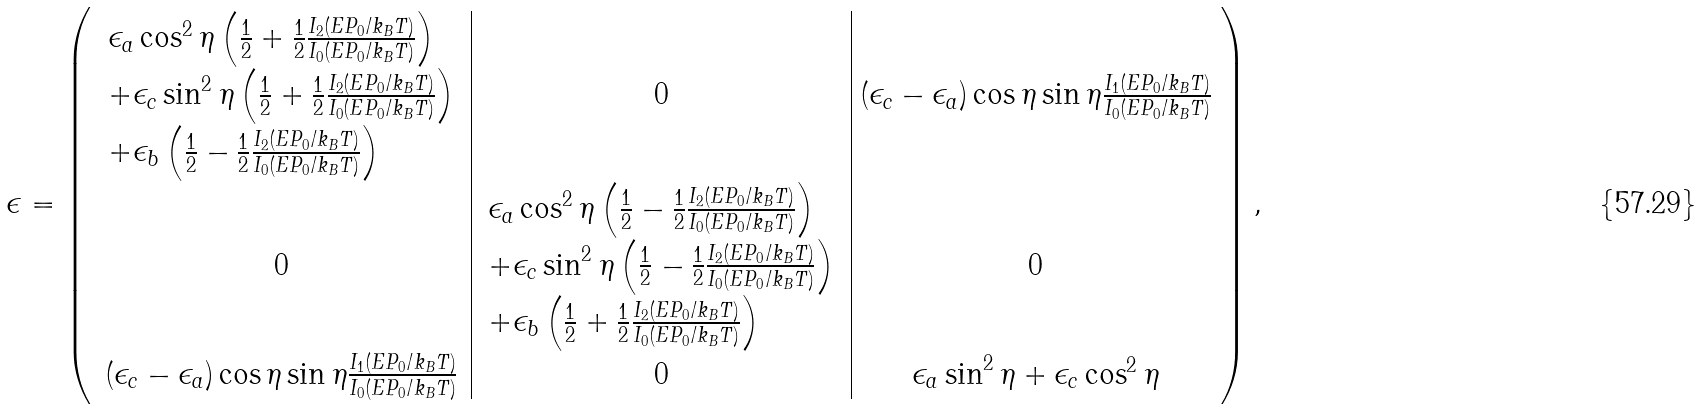<formula> <loc_0><loc_0><loc_500><loc_500>\epsilon = \left ( \begin{array} { c | c | c } \begin{array} { l } \epsilon _ { a } \cos ^ { 2 } \eta \left ( \frac { 1 } { 2 } + \frac { 1 } { 2 } \frac { I _ { 2 } ( E P _ { 0 } / k _ { B } T ) } { I _ { 0 } ( E P _ { 0 } / k _ { B } T ) } \right ) \\ + \epsilon _ { c } \sin ^ { 2 } \eta \left ( \frac { 1 } { 2 } + \frac { 1 } { 2 } \frac { I _ { 2 } ( E P _ { 0 } / k _ { B } T ) } { I _ { 0 } ( E P _ { 0 } / k _ { B } T ) } \right ) \\ + \epsilon _ { b } \left ( \frac { 1 } { 2 } - \frac { 1 } { 2 } \frac { I _ { 2 } ( E P _ { 0 } / k _ { B } T ) } { I _ { 0 } ( E P _ { 0 } / k _ { B } T ) } \right ) \end{array} & 0 & ( \epsilon _ { c } - \epsilon _ { a } ) \cos \eta \sin \eta \frac { I _ { 1 } ( E P _ { 0 } / k _ { B } T ) } { I _ { 0 } ( E P _ { 0 } / k _ { B } T ) } \\ 0 & \begin{array} { l } \epsilon _ { a } \cos ^ { 2 } \eta \left ( \frac { 1 } { 2 } - \frac { 1 } { 2 } \frac { I _ { 2 } ( E P _ { 0 } / k _ { B } T ) } { I _ { 0 } ( E P _ { 0 } / k _ { B } T ) } \right ) \\ + \epsilon _ { c } \sin ^ { 2 } \eta \left ( \frac { 1 } { 2 } - \frac { 1 } { 2 } \frac { I _ { 2 } ( E P _ { 0 } / k _ { B } T ) } { I _ { 0 } ( E P _ { 0 } / k _ { B } T ) } \right ) \\ + \epsilon _ { b } \left ( \frac { 1 } { 2 } + \frac { 1 } { 2 } \frac { I _ { 2 } ( E P _ { 0 } / k _ { B } T ) } { I _ { 0 } ( E P _ { 0 } / k _ { B } T ) } \right ) \end{array} & 0 \\ ( \epsilon _ { c } - \epsilon _ { a } ) \cos \eta \sin \eta \frac { I _ { 1 } ( E P _ { 0 } / k _ { B } T ) } { I _ { 0 } ( E P _ { 0 } / k _ { B } T ) } & 0 & \epsilon _ { a } \sin ^ { 2 } \eta + \epsilon _ { c } \cos ^ { 2 } \eta \end{array} \right ) ,</formula> 